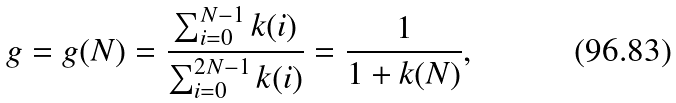Convert formula to latex. <formula><loc_0><loc_0><loc_500><loc_500>g = g ( N ) = \frac { \sum ^ { N - 1 } _ { i = 0 } k ( i ) } { \sum ^ { 2 N - 1 } _ { i = 0 } k ( i ) } = \frac { 1 } { 1 + k ( N ) } ,</formula> 